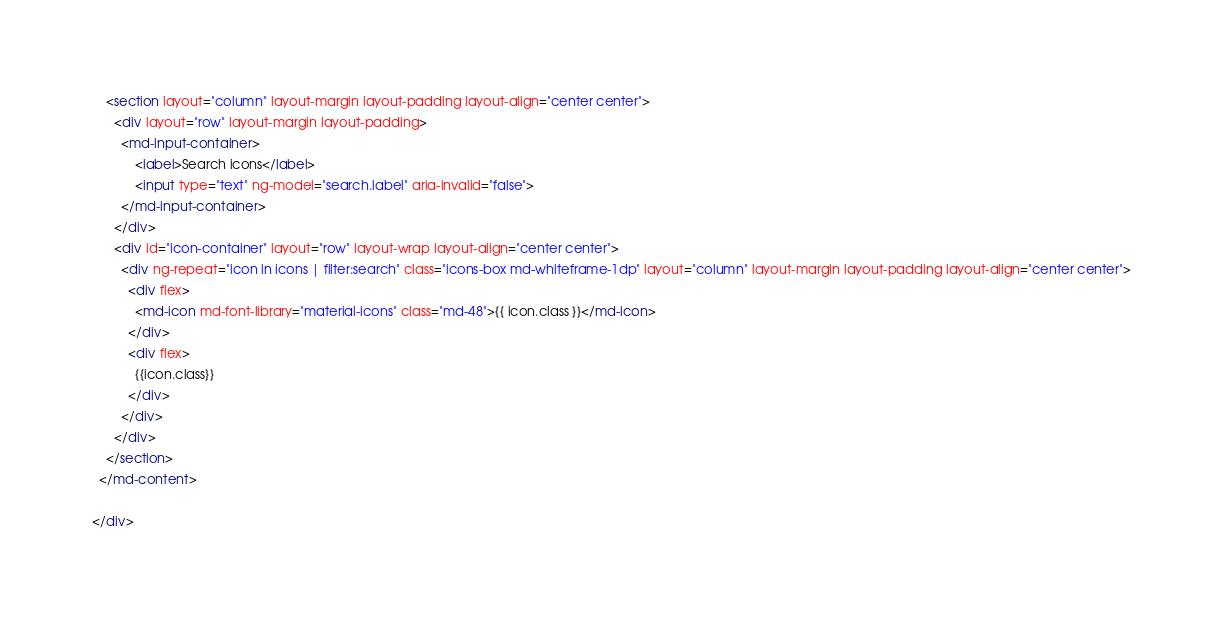<code> <loc_0><loc_0><loc_500><loc_500><_HTML_>    <section layout="column" layout-margin layout-padding layout-align="center center">
      <div layout="row" layout-margin layout-padding>
        <md-input-container>
            <label>Search icons</label>
            <input type="text" ng-model="search.label" aria-invalid="false">
        </md-input-container>
      </div>
      <div id="icon-container" layout="row" layout-wrap layout-align="center center">
        <div ng-repeat="icon in icons | filter:search" class="icons-box md-whiteframe-1dp" layout="column" layout-margin layout-padding layout-align="center center">
          <div flex>
            <md-icon md-font-library="material-icons" class="md-48">{{ icon.class }}</md-icon>
          </div>
          <div flex>
            {{icon.class}}
          </div>
        </div>
      </div>
    </section>
  </md-content>

</div></code> 